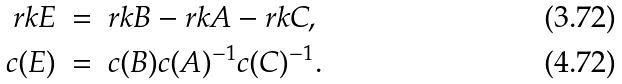<formula> <loc_0><loc_0><loc_500><loc_500>r k E & \ = \ r k B - r k A - r k C , \\ c ( E ) & \ = \ c ( B ) c ( A ) ^ { - 1 } c ( C ) ^ { - 1 } .</formula> 